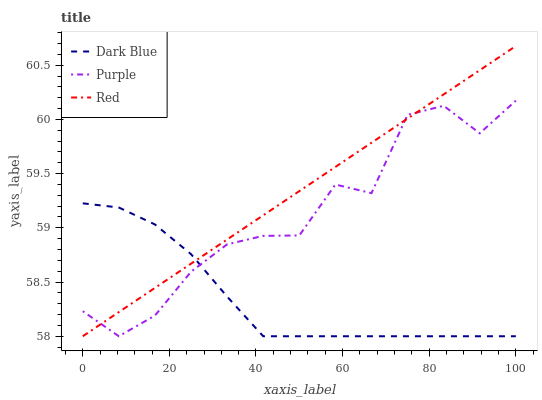Does Red have the minimum area under the curve?
Answer yes or no. No. Does Dark Blue have the maximum area under the curve?
Answer yes or no. No. Is Dark Blue the smoothest?
Answer yes or no. No. Is Dark Blue the roughest?
Answer yes or no. No. Does Dark Blue have the highest value?
Answer yes or no. No. 